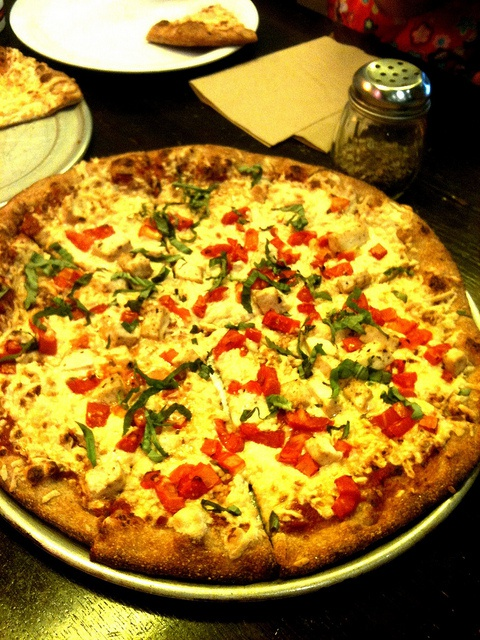Describe the objects in this image and their specific colors. I can see pizza in khaki, yellow, orange, red, and gold tones and pizza in khaki, red, orange, gold, and maroon tones in this image. 